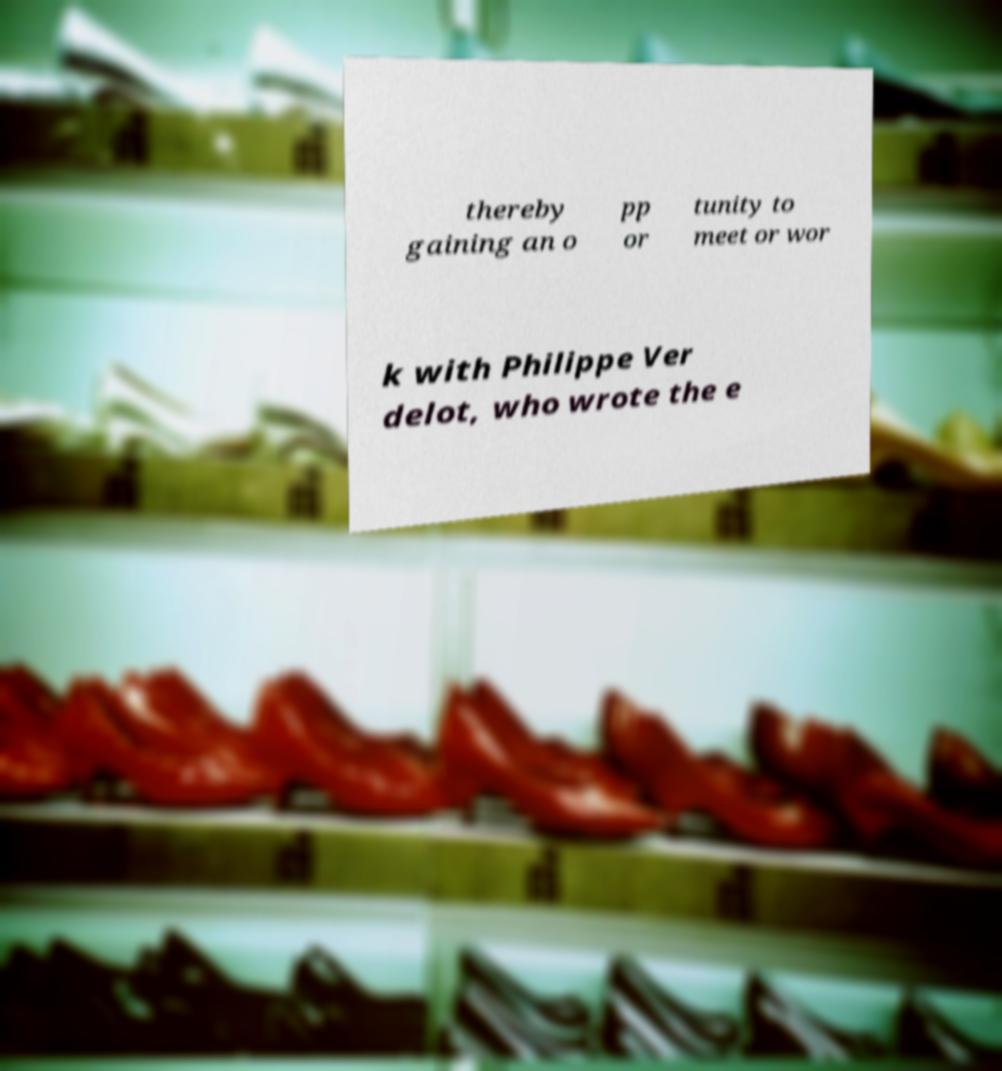Please read and relay the text visible in this image. What does it say? thereby gaining an o pp or tunity to meet or wor k with Philippe Ver delot, who wrote the e 